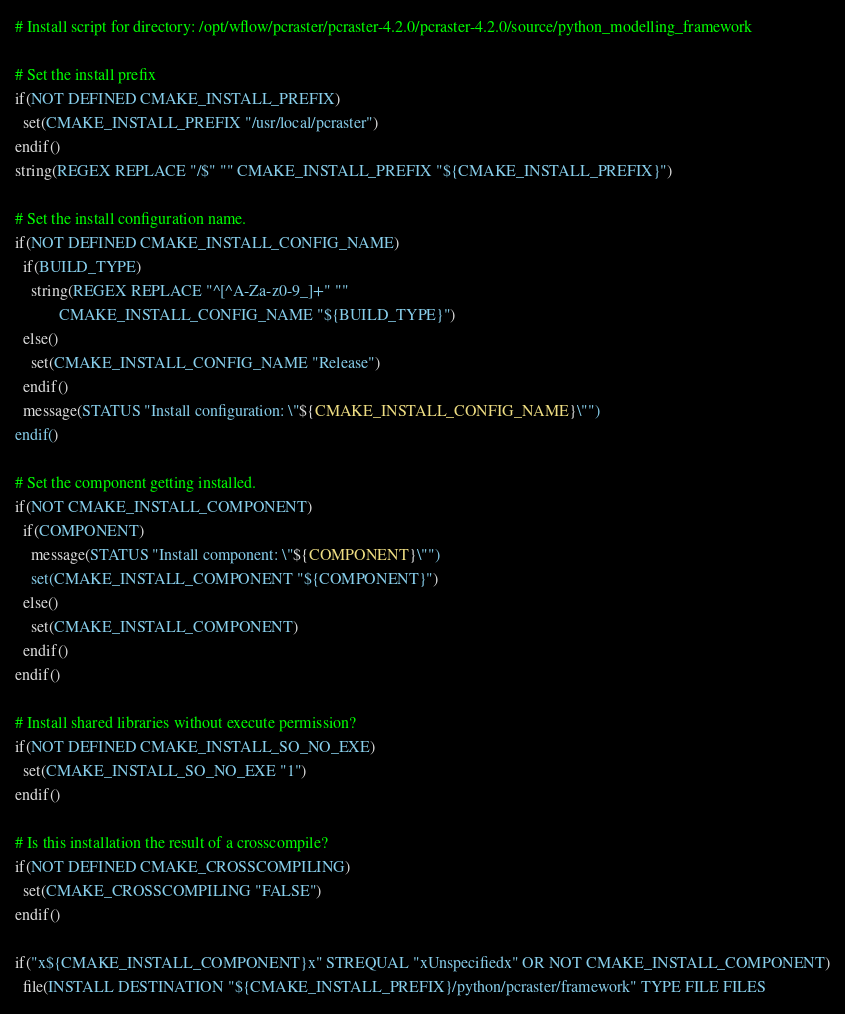Convert code to text. <code><loc_0><loc_0><loc_500><loc_500><_CMake_># Install script for directory: /opt/wflow/pcraster/pcraster-4.2.0/pcraster-4.2.0/source/python_modelling_framework

# Set the install prefix
if(NOT DEFINED CMAKE_INSTALL_PREFIX)
  set(CMAKE_INSTALL_PREFIX "/usr/local/pcraster")
endif()
string(REGEX REPLACE "/$" "" CMAKE_INSTALL_PREFIX "${CMAKE_INSTALL_PREFIX}")

# Set the install configuration name.
if(NOT DEFINED CMAKE_INSTALL_CONFIG_NAME)
  if(BUILD_TYPE)
    string(REGEX REPLACE "^[^A-Za-z0-9_]+" ""
           CMAKE_INSTALL_CONFIG_NAME "${BUILD_TYPE}")
  else()
    set(CMAKE_INSTALL_CONFIG_NAME "Release")
  endif()
  message(STATUS "Install configuration: \"${CMAKE_INSTALL_CONFIG_NAME}\"")
endif()

# Set the component getting installed.
if(NOT CMAKE_INSTALL_COMPONENT)
  if(COMPONENT)
    message(STATUS "Install component: \"${COMPONENT}\"")
    set(CMAKE_INSTALL_COMPONENT "${COMPONENT}")
  else()
    set(CMAKE_INSTALL_COMPONENT)
  endif()
endif()

# Install shared libraries without execute permission?
if(NOT DEFINED CMAKE_INSTALL_SO_NO_EXE)
  set(CMAKE_INSTALL_SO_NO_EXE "1")
endif()

# Is this installation the result of a crosscompile?
if(NOT DEFINED CMAKE_CROSSCOMPILING)
  set(CMAKE_CROSSCOMPILING "FALSE")
endif()

if("x${CMAKE_INSTALL_COMPONENT}x" STREQUAL "xUnspecifiedx" OR NOT CMAKE_INSTALL_COMPONENT)
  file(INSTALL DESTINATION "${CMAKE_INSTALL_PREFIX}/python/pcraster/framework" TYPE FILE FILES</code> 